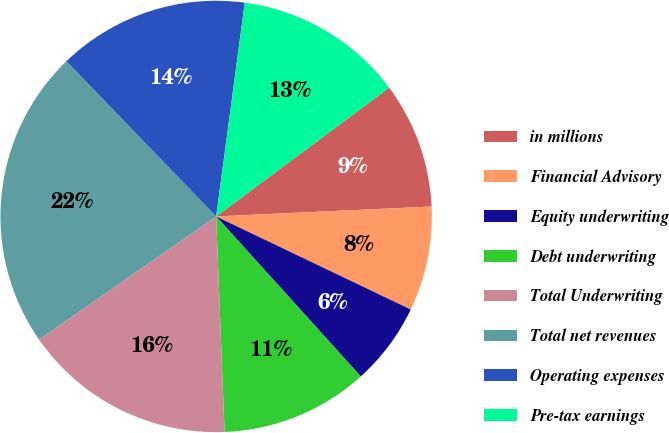Convert chart to OTSL. <chart><loc_0><loc_0><loc_500><loc_500><pie_chart><fcel>in millions<fcel>Financial Advisory<fcel>Equity underwriting<fcel>Debt underwriting<fcel>Total Underwriting<fcel>Total net revenues<fcel>Operating expenses<fcel>Pre-tax earnings<nl><fcel>9.45%<fcel>7.83%<fcel>6.2%<fcel>11.08%<fcel>15.95%<fcel>22.45%<fcel>14.33%<fcel>12.7%<nl></chart> 